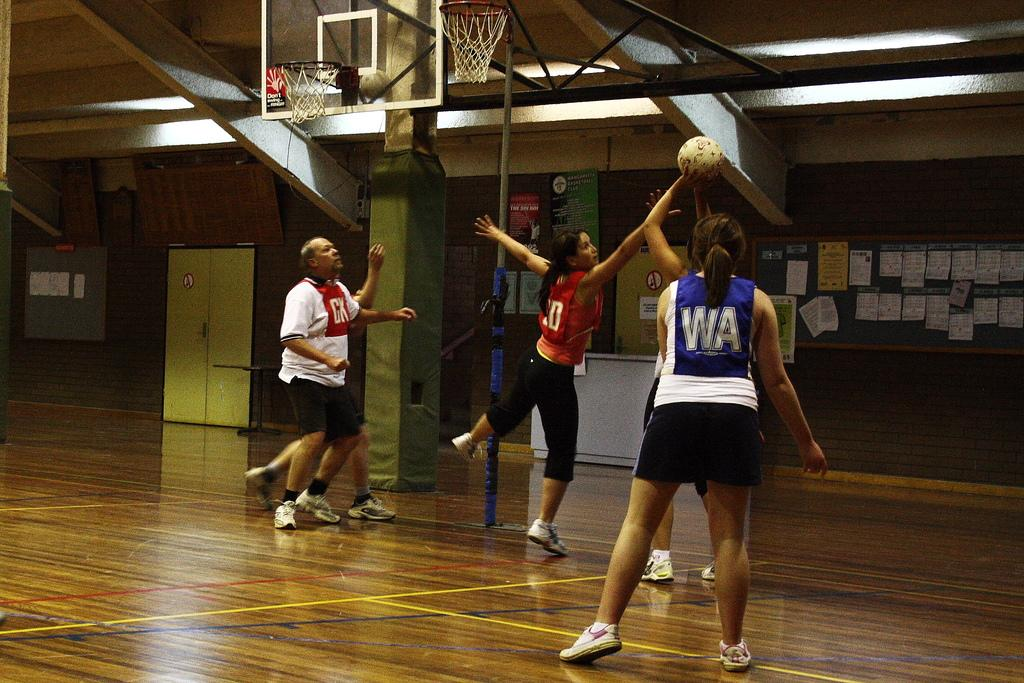<image>
Render a clear and concise summary of the photo. The player for CK tries to block the shot of of the player for WA. 